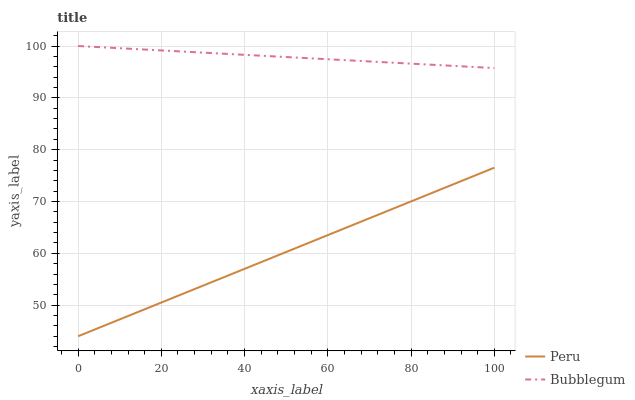Does Peru have the minimum area under the curve?
Answer yes or no. Yes. Does Bubblegum have the maximum area under the curve?
Answer yes or no. Yes. Does Peru have the maximum area under the curve?
Answer yes or no. No. Is Bubblegum the smoothest?
Answer yes or no. Yes. Is Peru the roughest?
Answer yes or no. Yes. Is Peru the smoothest?
Answer yes or no. No. Does Peru have the lowest value?
Answer yes or no. Yes. Does Bubblegum have the highest value?
Answer yes or no. Yes. Does Peru have the highest value?
Answer yes or no. No. Is Peru less than Bubblegum?
Answer yes or no. Yes. Is Bubblegum greater than Peru?
Answer yes or no. Yes. Does Peru intersect Bubblegum?
Answer yes or no. No. 